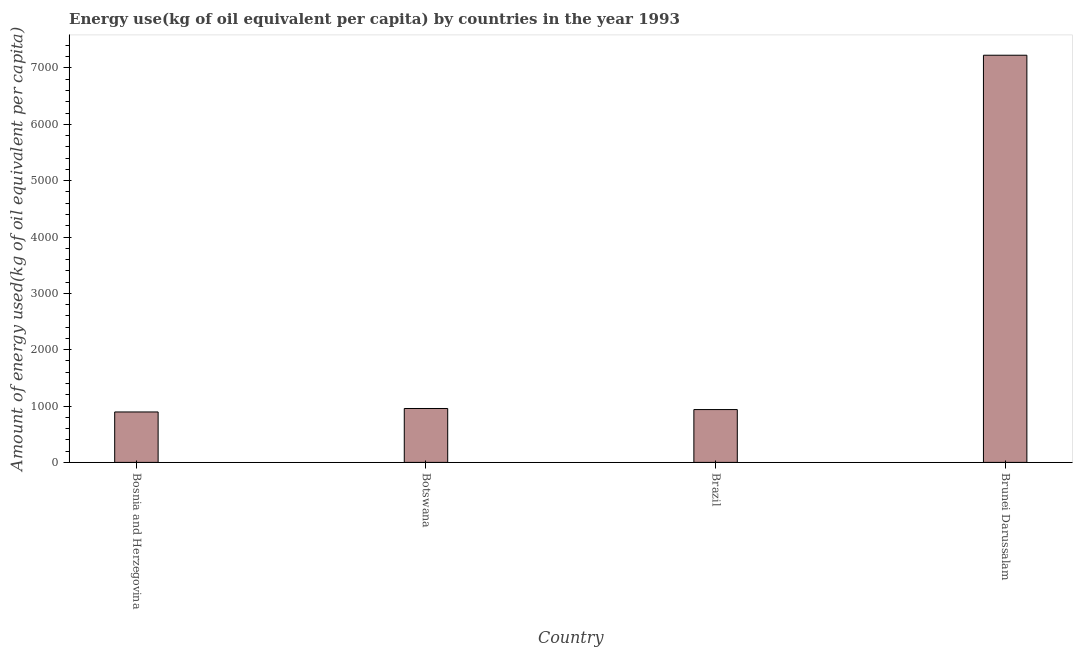Does the graph contain any zero values?
Keep it short and to the point. No. What is the title of the graph?
Ensure brevity in your answer.  Energy use(kg of oil equivalent per capita) by countries in the year 1993. What is the label or title of the X-axis?
Provide a short and direct response. Country. What is the label or title of the Y-axis?
Your answer should be very brief. Amount of energy used(kg of oil equivalent per capita). What is the amount of energy used in Bosnia and Herzegovina?
Ensure brevity in your answer.  895.03. Across all countries, what is the maximum amount of energy used?
Offer a terse response. 7226. Across all countries, what is the minimum amount of energy used?
Provide a short and direct response. 895.03. In which country was the amount of energy used maximum?
Your response must be concise. Brunei Darussalam. In which country was the amount of energy used minimum?
Provide a succinct answer. Bosnia and Herzegovina. What is the sum of the amount of energy used?
Keep it short and to the point. 1.00e+04. What is the difference between the amount of energy used in Botswana and Brazil?
Ensure brevity in your answer.  19. What is the average amount of energy used per country?
Your response must be concise. 2503.79. What is the median amount of energy used?
Your answer should be compact. 947.07. In how many countries, is the amount of energy used greater than 4600 kg?
Provide a succinct answer. 1. What is the ratio of the amount of energy used in Bosnia and Herzegovina to that in Brazil?
Your response must be concise. 0.95. Is the amount of energy used in Bosnia and Herzegovina less than that in Brunei Darussalam?
Make the answer very short. Yes. Is the difference between the amount of energy used in Bosnia and Herzegovina and Botswana greater than the difference between any two countries?
Keep it short and to the point. No. What is the difference between the highest and the second highest amount of energy used?
Ensure brevity in your answer.  6269.43. Is the sum of the amount of energy used in Bosnia and Herzegovina and Brazil greater than the maximum amount of energy used across all countries?
Your answer should be compact. No. What is the difference between the highest and the lowest amount of energy used?
Give a very brief answer. 6330.97. In how many countries, is the amount of energy used greater than the average amount of energy used taken over all countries?
Give a very brief answer. 1. How many bars are there?
Your answer should be compact. 4. How many countries are there in the graph?
Offer a very short reply. 4. What is the difference between two consecutive major ticks on the Y-axis?
Provide a short and direct response. 1000. Are the values on the major ticks of Y-axis written in scientific E-notation?
Your response must be concise. No. What is the Amount of energy used(kg of oil equivalent per capita) in Bosnia and Herzegovina?
Make the answer very short. 895.03. What is the Amount of energy used(kg of oil equivalent per capita) in Botswana?
Your answer should be compact. 956.57. What is the Amount of energy used(kg of oil equivalent per capita) in Brazil?
Offer a very short reply. 937.57. What is the Amount of energy used(kg of oil equivalent per capita) in Brunei Darussalam?
Make the answer very short. 7226. What is the difference between the Amount of energy used(kg of oil equivalent per capita) in Bosnia and Herzegovina and Botswana?
Make the answer very short. -61.55. What is the difference between the Amount of energy used(kg of oil equivalent per capita) in Bosnia and Herzegovina and Brazil?
Offer a terse response. -42.54. What is the difference between the Amount of energy used(kg of oil equivalent per capita) in Bosnia and Herzegovina and Brunei Darussalam?
Offer a terse response. -6330.97. What is the difference between the Amount of energy used(kg of oil equivalent per capita) in Botswana and Brazil?
Make the answer very short. 19. What is the difference between the Amount of energy used(kg of oil equivalent per capita) in Botswana and Brunei Darussalam?
Your response must be concise. -6269.43. What is the difference between the Amount of energy used(kg of oil equivalent per capita) in Brazil and Brunei Darussalam?
Provide a succinct answer. -6288.43. What is the ratio of the Amount of energy used(kg of oil equivalent per capita) in Bosnia and Herzegovina to that in Botswana?
Make the answer very short. 0.94. What is the ratio of the Amount of energy used(kg of oil equivalent per capita) in Bosnia and Herzegovina to that in Brazil?
Ensure brevity in your answer.  0.95. What is the ratio of the Amount of energy used(kg of oil equivalent per capita) in Bosnia and Herzegovina to that in Brunei Darussalam?
Make the answer very short. 0.12. What is the ratio of the Amount of energy used(kg of oil equivalent per capita) in Botswana to that in Brunei Darussalam?
Make the answer very short. 0.13. What is the ratio of the Amount of energy used(kg of oil equivalent per capita) in Brazil to that in Brunei Darussalam?
Provide a short and direct response. 0.13. 